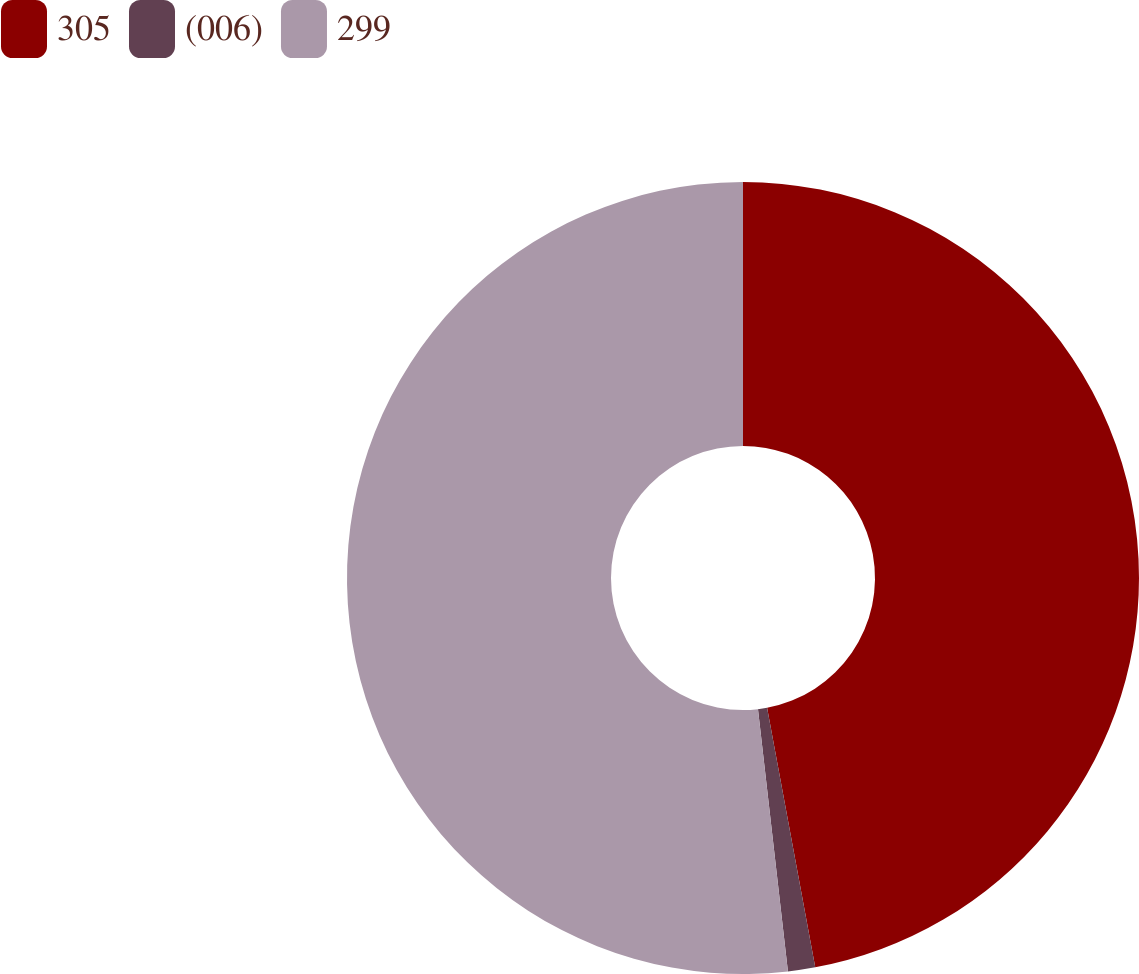<chart> <loc_0><loc_0><loc_500><loc_500><pie_chart><fcel>305<fcel>(006)<fcel>299<nl><fcel>47.08%<fcel>1.11%<fcel>51.81%<nl></chart> 